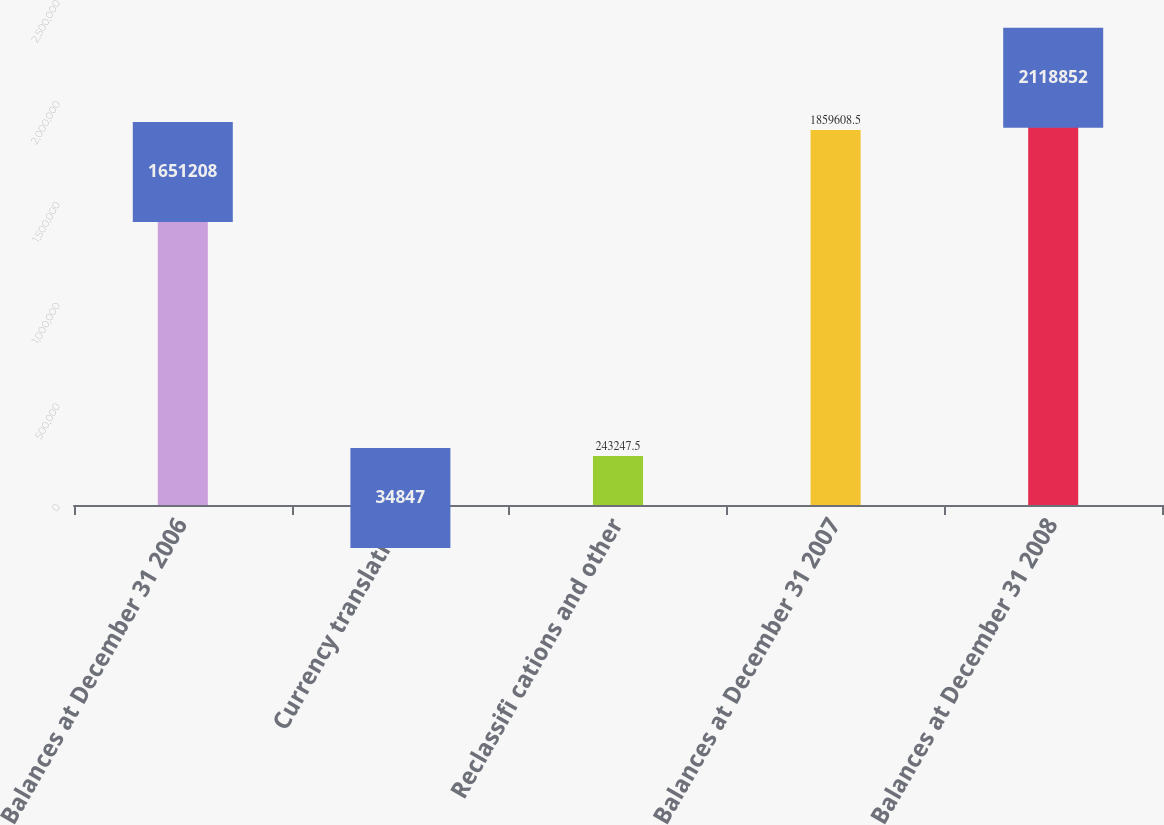Convert chart. <chart><loc_0><loc_0><loc_500><loc_500><bar_chart><fcel>Balances at December 31 2006<fcel>Currency translation<fcel>Reclassifi cations and other<fcel>Balances at December 31 2007<fcel>Balances at December 31 2008<nl><fcel>1.65121e+06<fcel>34847<fcel>243248<fcel>1.85961e+06<fcel>2.11885e+06<nl></chart> 